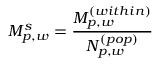Convert formula to latex. <formula><loc_0><loc_0><loc_500><loc_500>M _ { p , w } ^ { s } = \frac { M _ { p , w } ^ { ( w i t h i n ) } } { N _ { p , w } ^ { ( p o p ) } }</formula> 